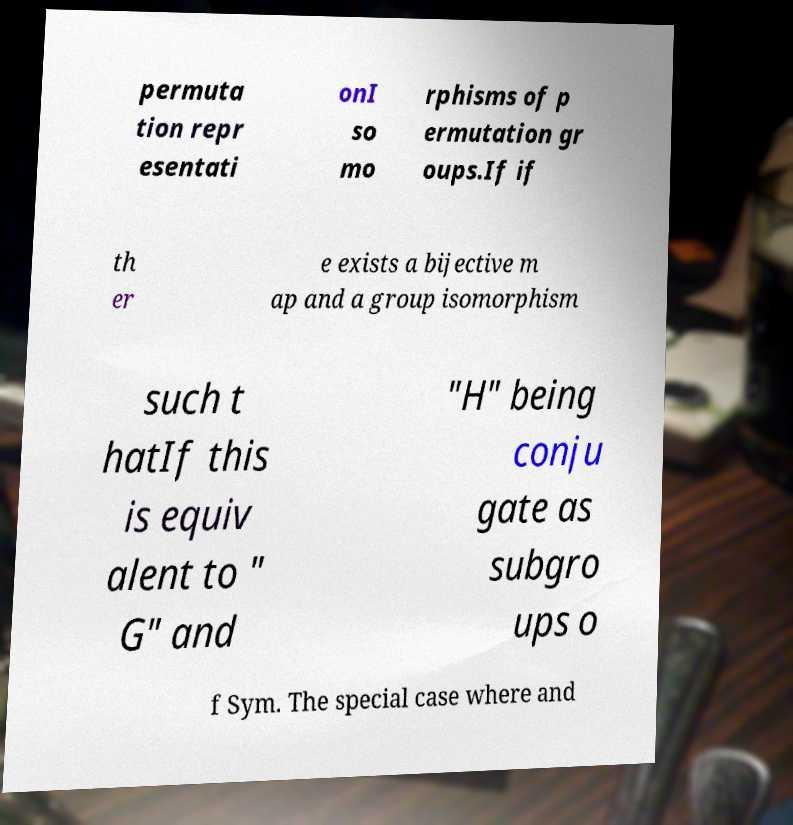Could you assist in decoding the text presented in this image and type it out clearly? permuta tion repr esentati onI so mo rphisms of p ermutation gr oups.If if th er e exists a bijective m ap and a group isomorphism such t hatIf this is equiv alent to " G" and "H" being conju gate as subgro ups o f Sym. The special case where and 